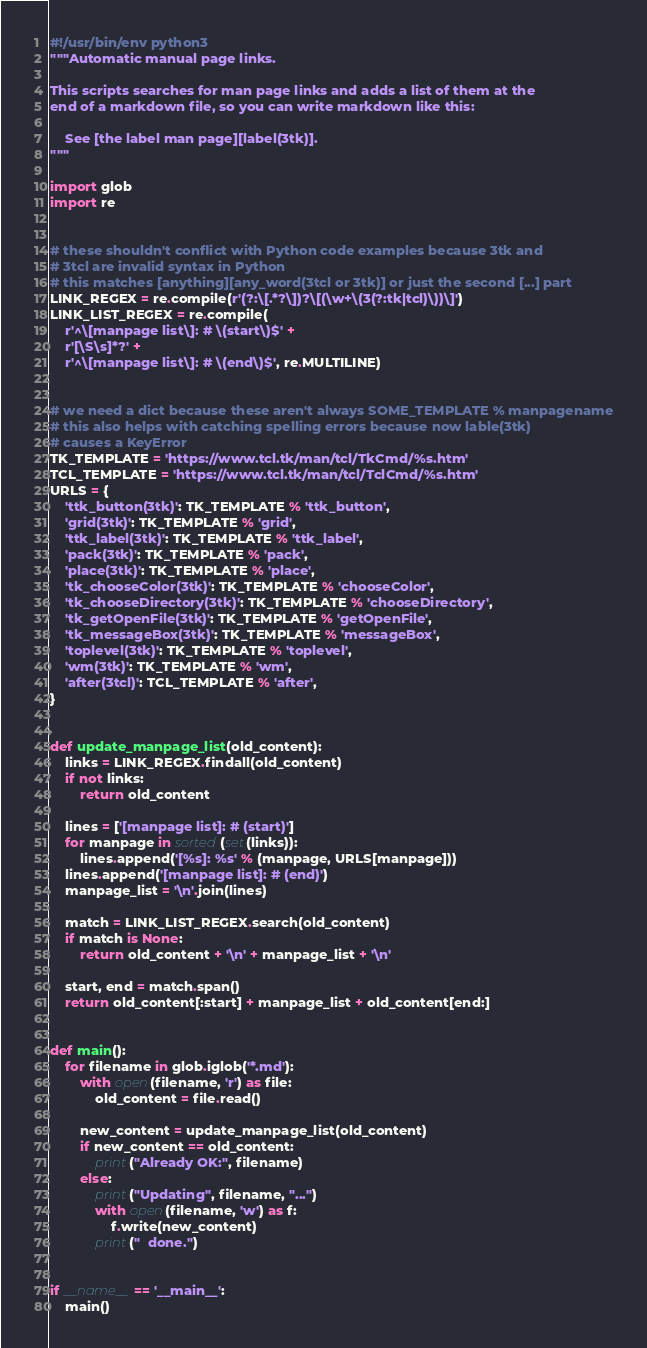<code> <loc_0><loc_0><loc_500><loc_500><_Python_>#!/usr/bin/env python3
"""Automatic manual page links.

This scripts searches for man page links and adds a list of them at the
end of a markdown file, so you can write markdown like this:

    See [the label man page][label(3tk)].
"""

import glob
import re


# these shouldn't conflict with Python code examples because 3tk and
# 3tcl are invalid syntax in Python
# this matches [anything][any_word(3tcl or 3tk)] or just the second [...] part
LINK_REGEX = re.compile(r'(?:\[.*?\])?\[(\w+\(3(?:tk|tcl)\))\]')
LINK_LIST_REGEX = re.compile(
    r'^\[manpage list\]: # \(start\)$' +
    r'[\S\s]*?' +
    r'^\[manpage list\]: # \(end\)$', re.MULTILINE)


# we need a dict because these aren't always SOME_TEMPLATE % manpagename
# this also helps with catching spelling errors because now lable(3tk)
# causes a KeyError
TK_TEMPLATE = 'https://www.tcl.tk/man/tcl/TkCmd/%s.htm'
TCL_TEMPLATE = 'https://www.tcl.tk/man/tcl/TclCmd/%s.htm'
URLS = {
    'ttk_button(3tk)': TK_TEMPLATE % 'ttk_button',
    'grid(3tk)': TK_TEMPLATE % 'grid',
    'ttk_label(3tk)': TK_TEMPLATE % 'ttk_label',
    'pack(3tk)': TK_TEMPLATE % 'pack',
    'place(3tk)': TK_TEMPLATE % 'place',
    'tk_chooseColor(3tk)': TK_TEMPLATE % 'chooseColor',
    'tk_chooseDirectory(3tk)': TK_TEMPLATE % 'chooseDirectory',
    'tk_getOpenFile(3tk)': TK_TEMPLATE % 'getOpenFile',
    'tk_messageBox(3tk)': TK_TEMPLATE % 'messageBox',
    'toplevel(3tk)': TK_TEMPLATE % 'toplevel',
    'wm(3tk)': TK_TEMPLATE % 'wm',
    'after(3tcl)': TCL_TEMPLATE % 'after',
}


def update_manpage_list(old_content):
    links = LINK_REGEX.findall(old_content)
    if not links:
        return old_content

    lines = ['[manpage list]: # (start)']
    for manpage in sorted(set(links)):
        lines.append('[%s]: %s' % (manpage, URLS[manpage]))
    lines.append('[manpage list]: # (end)')
    manpage_list = '\n'.join(lines)

    match = LINK_LIST_REGEX.search(old_content)
    if match is None:
        return old_content + '\n' + manpage_list + '\n'

    start, end = match.span()
    return old_content[:start] + manpage_list + old_content[end:]


def main():
    for filename in glob.iglob('*.md'):
        with open(filename, 'r') as file:
            old_content = file.read()

        new_content = update_manpage_list(old_content)
        if new_content == old_content:
            print("Already OK:", filename)
        else:
            print("Updating", filename, "...")
            with open(filename, 'w') as f:
                f.write(new_content)
            print("  done.")


if __name__ == '__main__':
    main()
</code> 